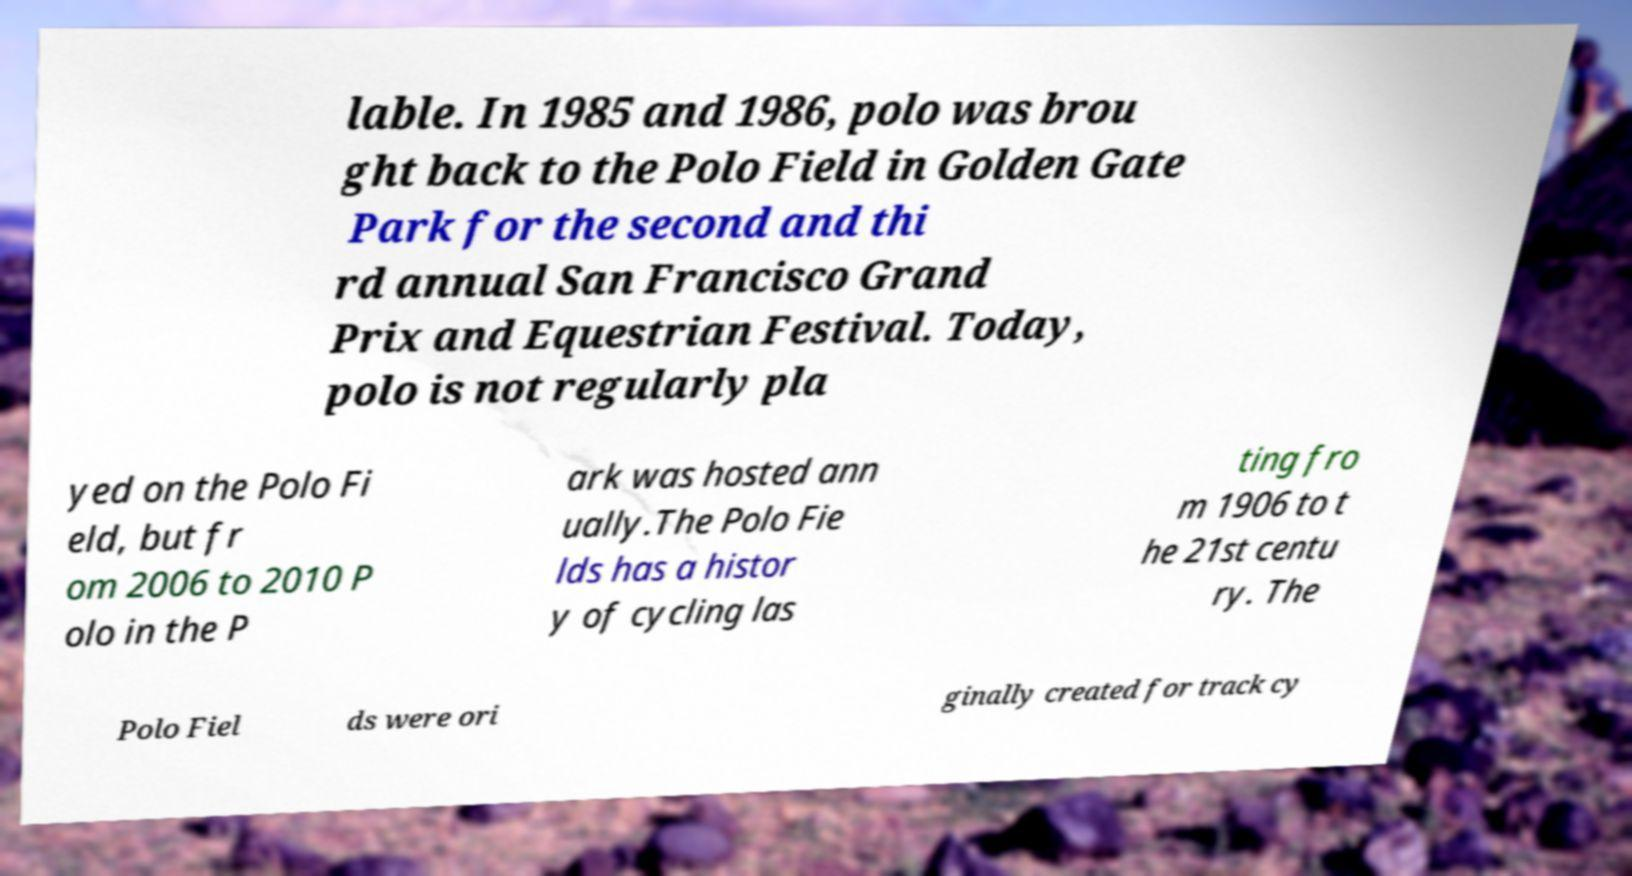Please identify and transcribe the text found in this image. lable. In 1985 and 1986, polo was brou ght back to the Polo Field in Golden Gate Park for the second and thi rd annual San Francisco Grand Prix and Equestrian Festival. Today, polo is not regularly pla yed on the Polo Fi eld, but fr om 2006 to 2010 P olo in the P ark was hosted ann ually.The Polo Fie lds has a histor y of cycling las ting fro m 1906 to t he 21st centu ry. The Polo Fiel ds were ori ginally created for track cy 